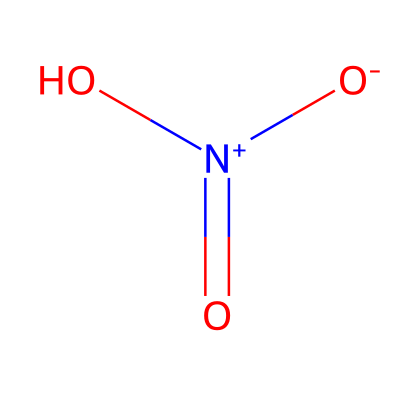What is the main functional group present in this structure? The chemical structure contains a nitro group, which is characterized by the presence of the nitrogen atom bonded to two oxygen atoms, one of which is positively charged and the other negatively charged.
Answer: nitro group How many oxygen atoms are in this chemical structure? By examining the structure, there are two oxygen atoms bonded to the nitrogen atom and one additional oxygen atom as part of the nitro functional group, for a total of three oxygen atoms.
Answer: three What is the oxidation state of nitrogen in this molecule? The nitrogen atom is bonded to three different oxygen atoms, with one of them being negatively charged and the others contributing to its oxidation state. The common oxidation state of nitrogen in this structure is +3.
Answer: +3 How many total atoms are present in this molecule? The molecule contains one nitrogen atom and three oxygen atoms, which adds up to a total of four atoms in the structure.
Answer: four What type of gas does this chemical primarily create in urban pollution? This chemical, which is nitrogen oxide, is primarily responsible for creating smog and contributing to the formation of acid rain, common in urban pollution scenarios.
Answer: nitrogen oxide Is this chemical likely to affect urban air quality? Yes, nitrogen oxides are known to be pollutants that can significantly deteriorate urban air quality, contributing to respiratory problems and environmental issues like ozone formation.
Answer: yes 